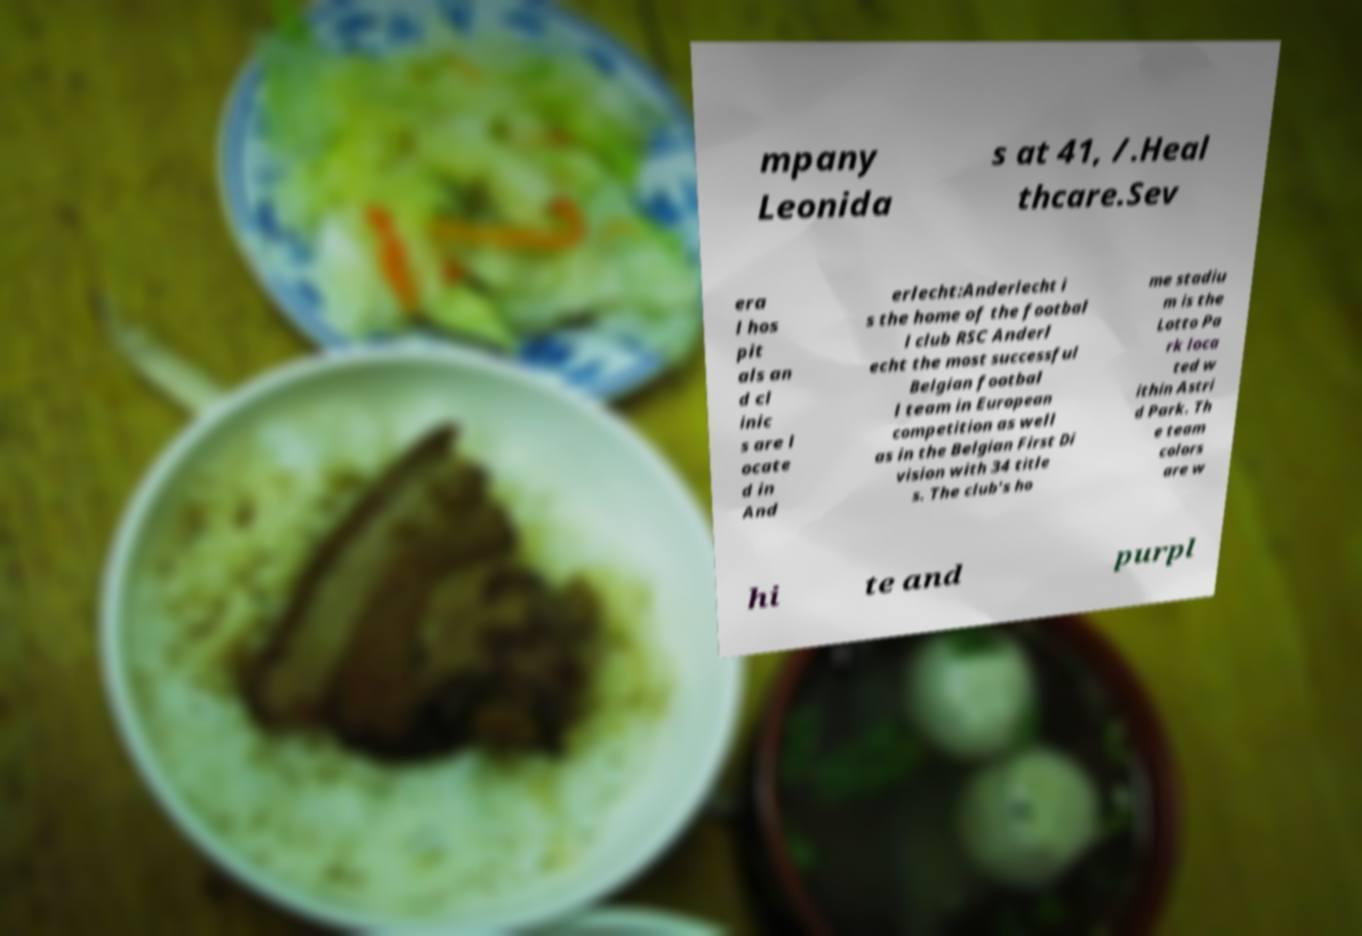Could you assist in decoding the text presented in this image and type it out clearly? mpany Leonida s at 41, /.Heal thcare.Sev era l hos pit als an d cl inic s are l ocate d in And erlecht:Anderlecht i s the home of the footbal l club RSC Anderl echt the most successful Belgian footbal l team in European competition as well as in the Belgian First Di vision with 34 title s. The club's ho me stadiu m is the Lotto Pa rk loca ted w ithin Astri d Park. Th e team colors are w hi te and purpl 